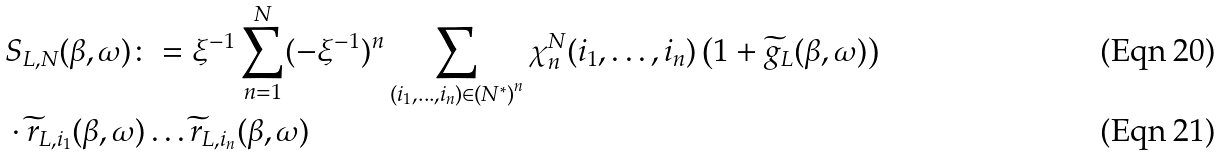Convert formula to latex. <formula><loc_0><loc_0><loc_500><loc_500>& S _ { L , N } ( \beta , \omega ) \colon = \xi ^ { - 1 } \sum _ { n = 1 } ^ { N } ( - \xi ^ { - 1 } ) ^ { n } \sum _ { ( i _ { 1 } , \dots , i _ { n } ) \in { ( N ^ { * } ) } ^ { n } } \chi _ { n } ^ { N } ( i _ { 1 } , \dots , i _ { n } ) \left ( 1 + \widetilde { g } _ { L } ( \beta , \omega ) \right ) \\ & \cdot \widetilde { r } _ { L , i _ { 1 } } ( \beta , \omega ) \dots \widetilde { r } _ { L , i _ { n } } ( \beta , \omega ) \,</formula> 